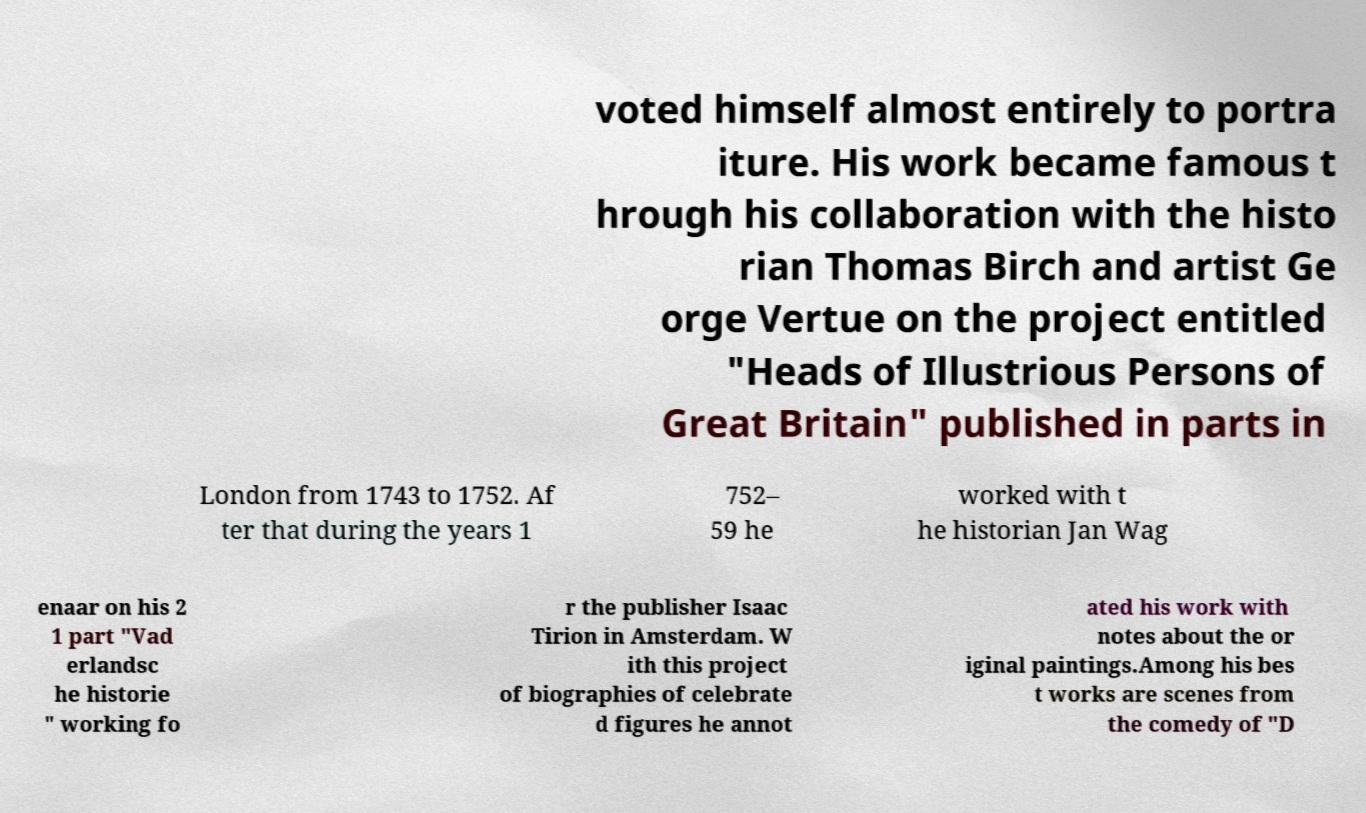Please identify and transcribe the text found in this image. voted himself almost entirely to portra iture. His work became famous t hrough his collaboration with the histo rian Thomas Birch and artist Ge orge Vertue on the project entitled "Heads of Illustrious Persons of Great Britain" published in parts in London from 1743 to 1752. Af ter that during the years 1 752– 59 he worked with t he historian Jan Wag enaar on his 2 1 part "Vad erlandsc he historie " working fo r the publisher Isaac Tirion in Amsterdam. W ith this project of biographies of celebrate d figures he annot ated his work with notes about the or iginal paintings.Among his bes t works are scenes from the comedy of "D 